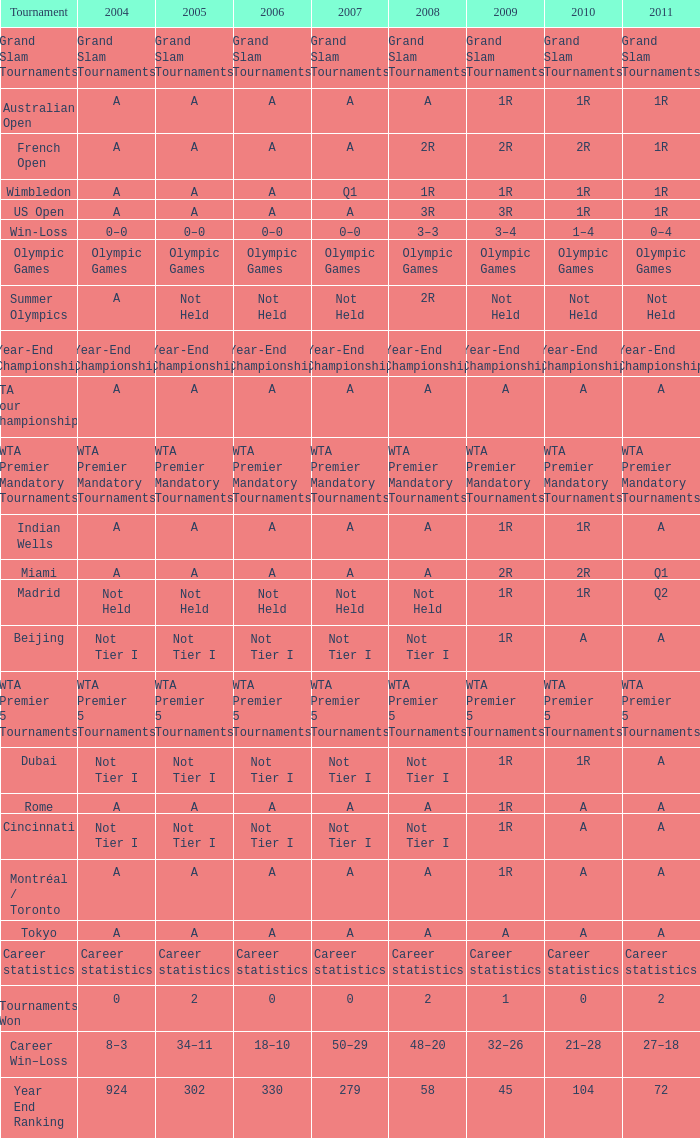What is the relevance of the year 2007 in relation to the "madrid" tournament? Not Held. 